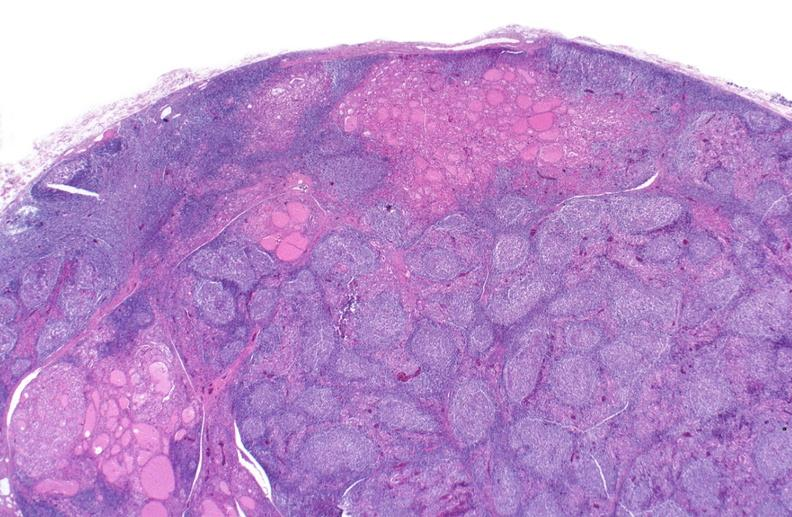does photo show hashimoto 's thyroiditis?
Answer the question using a single word or phrase. No 